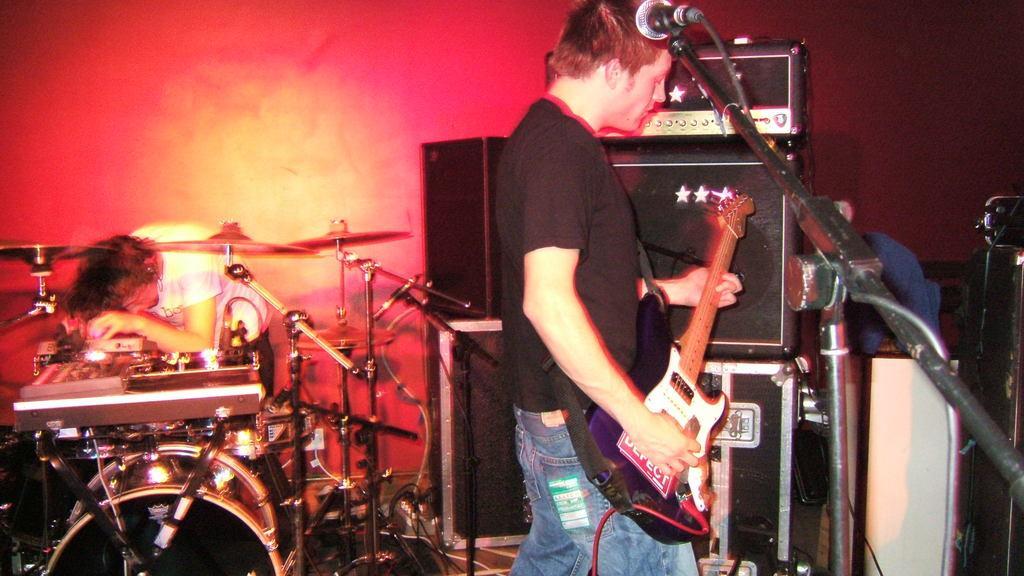How would you summarize this image in a sentence or two? In the middle of the image, there is person standing in front of the mike and playing a guitar. In the left middle, there is a person playing instruments. In the right middle, there is a person standing. In the background, there is a light of red and yellow in color. On the top right there is a sound box and speakers kept on the dais. This image is taken in a hall during night time. 